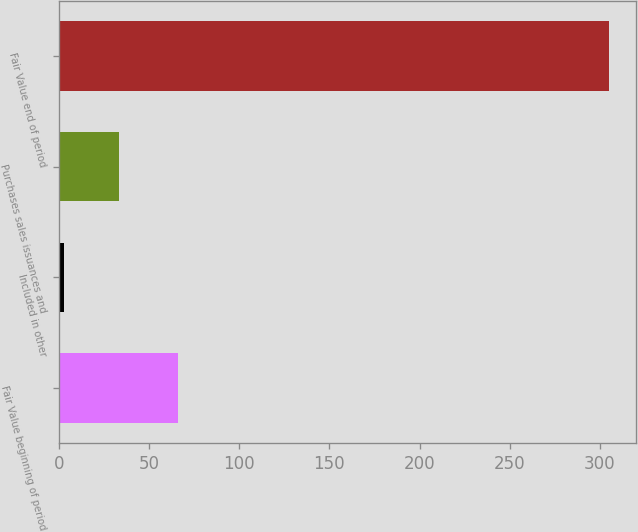Convert chart to OTSL. <chart><loc_0><loc_0><loc_500><loc_500><bar_chart><fcel>Fair Value beginning of period<fcel>Included in other<fcel>Purchases sales issuances and<fcel>Fair Value end of period<nl><fcel>66<fcel>3<fcel>33.2<fcel>305<nl></chart> 